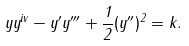Convert formula to latex. <formula><loc_0><loc_0><loc_500><loc_500>y y ^ { i v } - y ^ { \prime } y ^ { \prime \prime \prime } + \frac { 1 } { 2 } ( y ^ { \prime \prime } ) ^ { 2 } = k .</formula> 